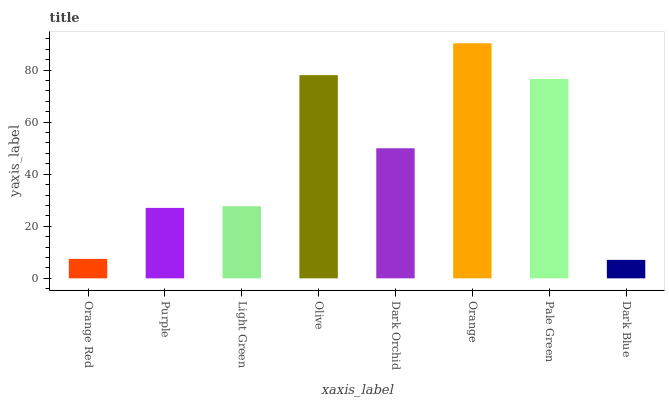Is Dark Blue the minimum?
Answer yes or no. Yes. Is Orange the maximum?
Answer yes or no. Yes. Is Purple the minimum?
Answer yes or no. No. Is Purple the maximum?
Answer yes or no. No. Is Purple greater than Orange Red?
Answer yes or no. Yes. Is Orange Red less than Purple?
Answer yes or no. Yes. Is Orange Red greater than Purple?
Answer yes or no. No. Is Purple less than Orange Red?
Answer yes or no. No. Is Dark Orchid the high median?
Answer yes or no. Yes. Is Light Green the low median?
Answer yes or no. Yes. Is Purple the high median?
Answer yes or no. No. Is Dark Blue the low median?
Answer yes or no. No. 